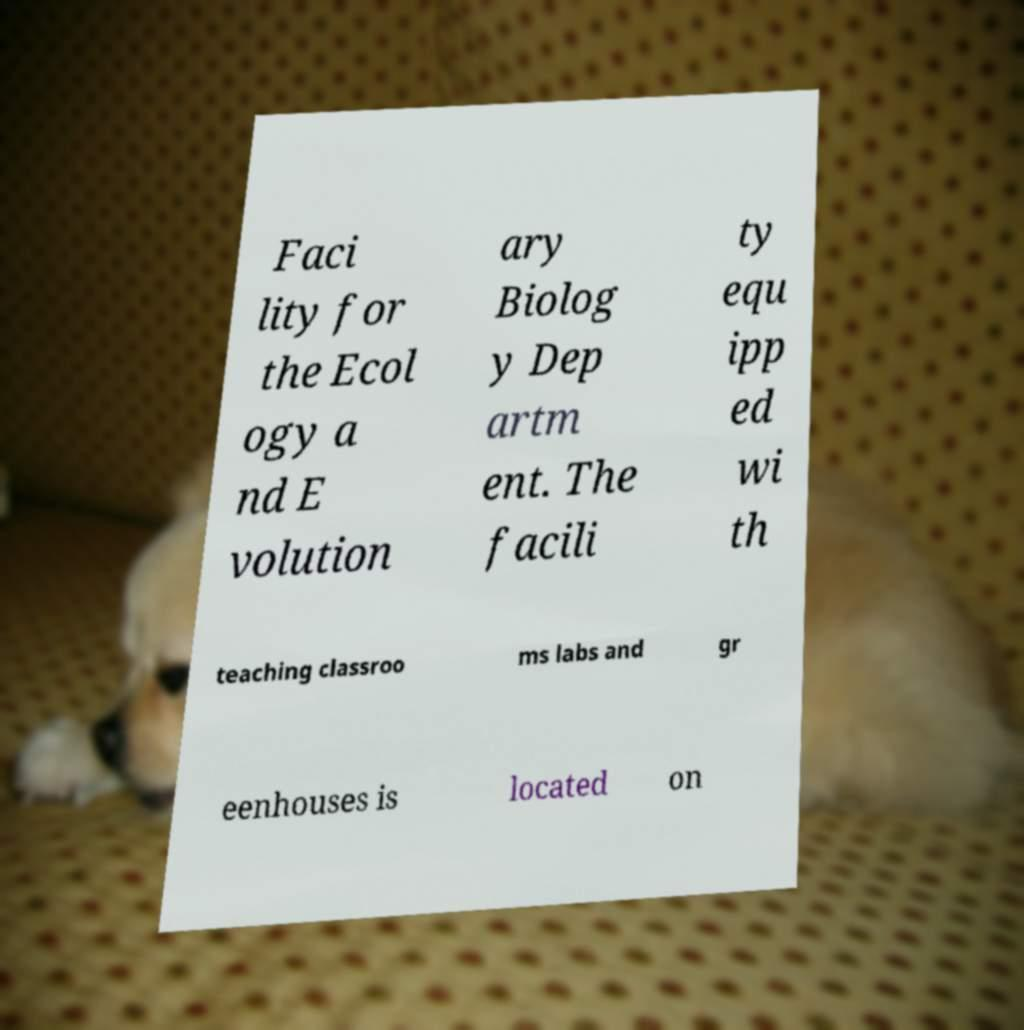Could you extract and type out the text from this image? Faci lity for the Ecol ogy a nd E volution ary Biolog y Dep artm ent. The facili ty equ ipp ed wi th teaching classroo ms labs and gr eenhouses is located on 